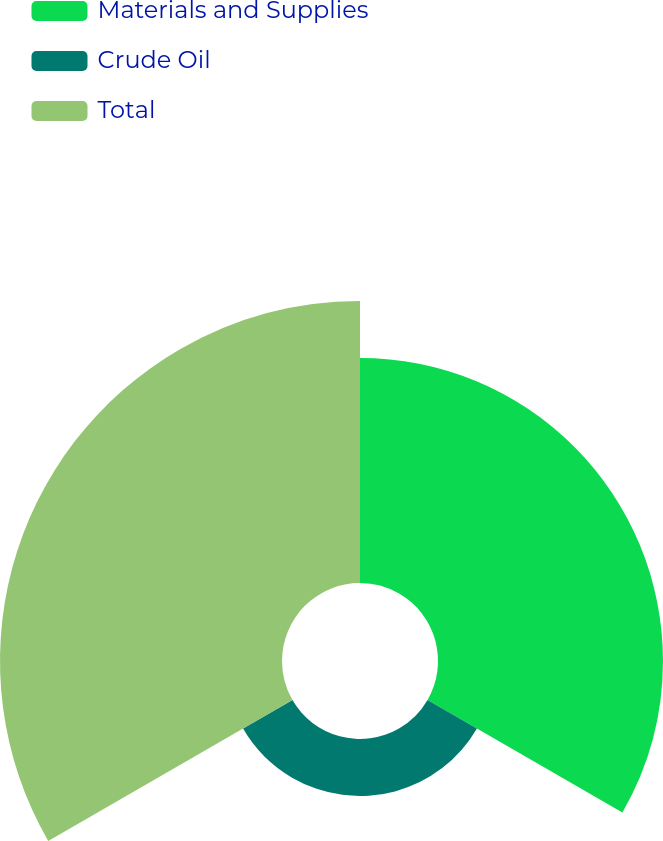Convert chart. <chart><loc_0><loc_0><loc_500><loc_500><pie_chart><fcel>Materials and Supplies<fcel>Crude Oil<fcel>Total<nl><fcel>39.89%<fcel>10.11%<fcel>50.0%<nl></chart> 